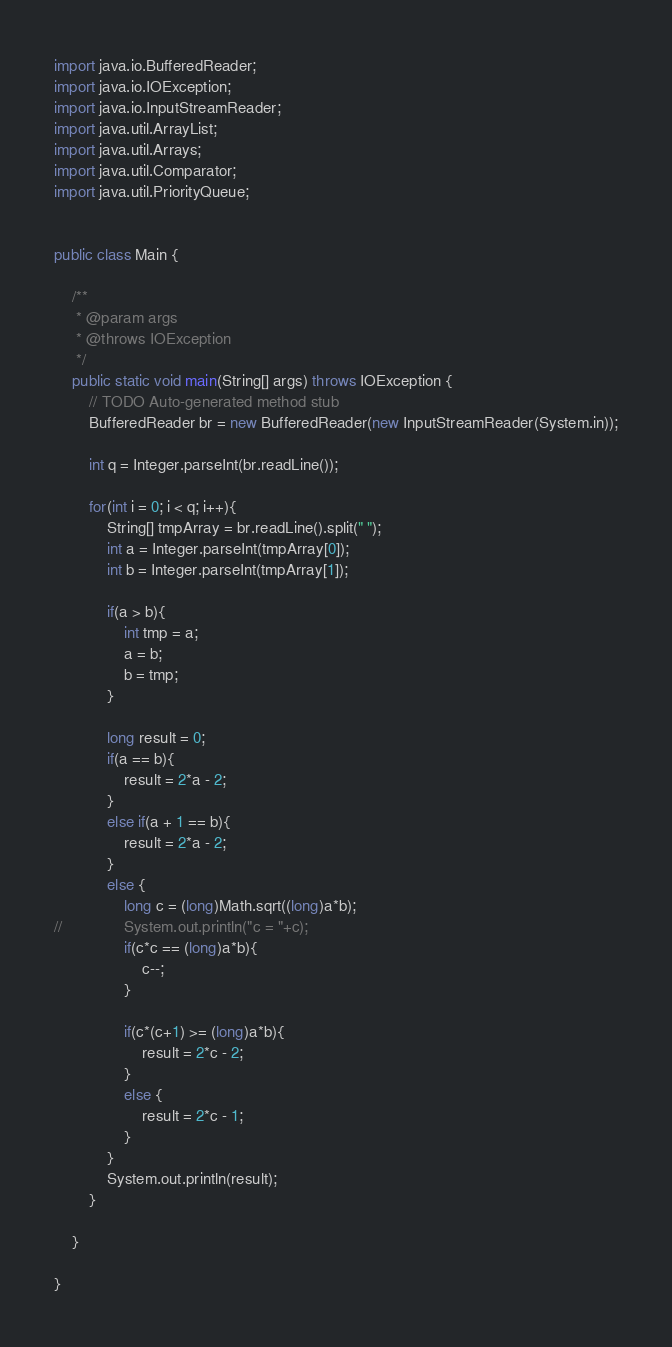Convert code to text. <code><loc_0><loc_0><loc_500><loc_500><_Java_>import java.io.BufferedReader;
import java.io.IOException;
import java.io.InputStreamReader;
import java.util.ArrayList;
import java.util.Arrays;
import java.util.Comparator;
import java.util.PriorityQueue;


public class Main {

	/**
	 * @param args
	 * @throws IOException 
	 */
	public static void main(String[] args) throws IOException {
		// TODO Auto-generated method stub
		BufferedReader br = new BufferedReader(new InputStreamReader(System.in));
		
		int q = Integer.parseInt(br.readLine());
		
		for(int i = 0; i < q; i++){
			String[] tmpArray = br.readLine().split(" ");
			int a = Integer.parseInt(tmpArray[0]);
			int b = Integer.parseInt(tmpArray[1]);
			
			if(a > b){
				int tmp = a;
				a = b;
				b = tmp;
			}
			
			long result = 0;
			if(a == b){
				result = 2*a - 2;
			}
			else if(a + 1 == b){
				result = 2*a - 2;
			}
			else {
				long c = (long)Math.sqrt((long)a*b);
//				System.out.println("c = "+c);
				if(c*c == (long)a*b){
					c--;
				}
				
				if(c*(c+1) >= (long)a*b){
					result = 2*c - 2;
				}
				else {
					result = 2*c - 1;
				}
			}
			System.out.println(result);
		}
		
	}

}</code> 